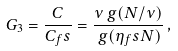Convert formula to latex. <formula><loc_0><loc_0><loc_500><loc_500>G _ { 3 } = \frac { C } { C _ { f } s } = \frac { \nu \, g ( N / \nu ) } { \, g ( \eta _ { f } s N ) } \, ,</formula> 